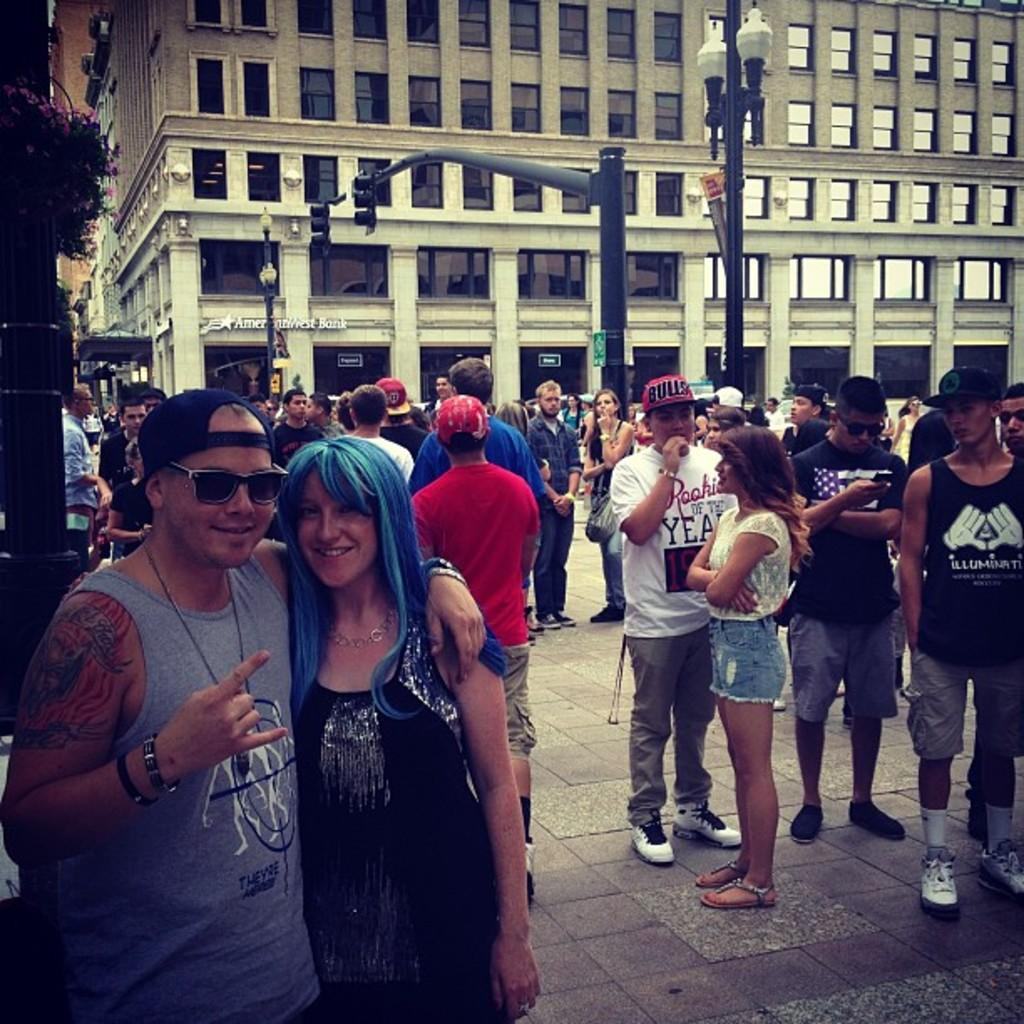What is happening in the image? There is a group of people standing in the image. What can be seen in the background of the image? There are lights, signal lights attached to poles, and buildings in the background of the image. Can you see any maids or archways in the image? There are no maids or archways present in the image. Are there any fairies flying around in the image? There are no fairies present in the image. 